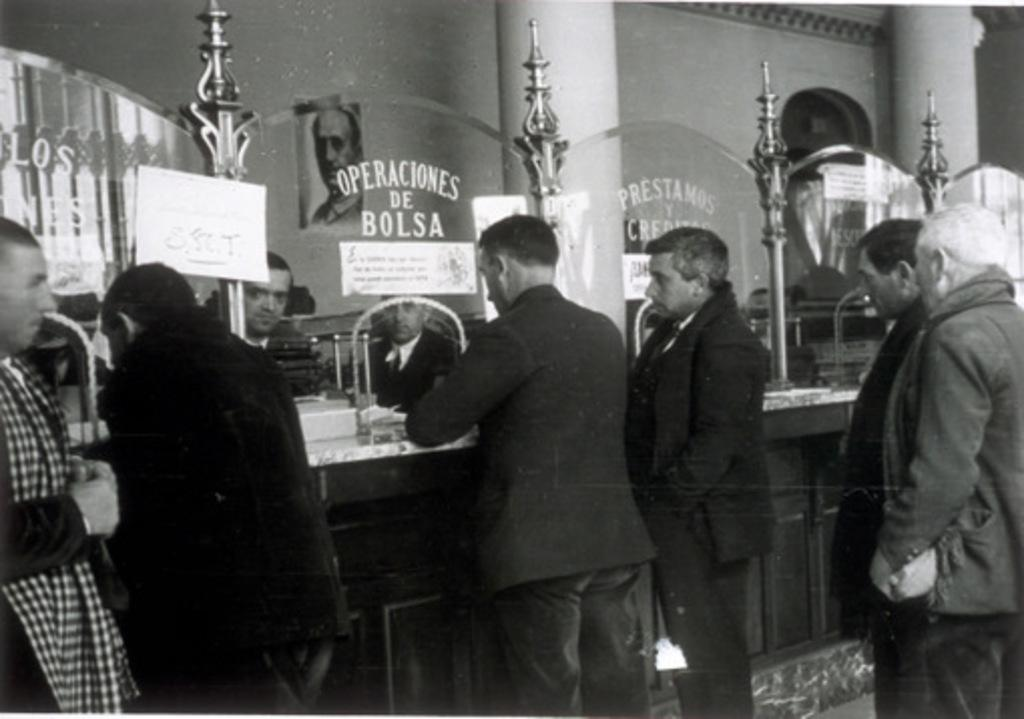What is the main setting of the image? The main setting of the image is a glass counter. What are the people in the image doing? The persons are standing in front of the glass counter. Are there any specific individuals in the group? Yes, there are two persons standing at the front of the group. Can you see any coastline in the image? There is no coastline visible in the image; it features a group of people standing in front of a glass counter. What type of horn is being played by the person in the back of the group? There is no person playing a horn in the image, nor is there anyone in the back of the group. 